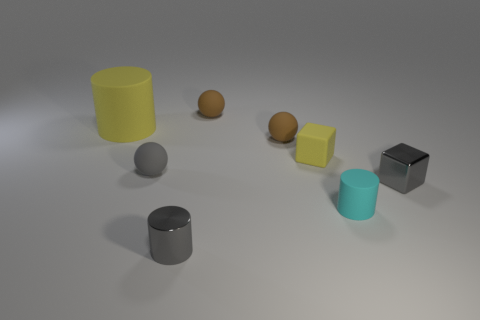Is there anything else that is the same size as the yellow cylinder?
Offer a very short reply. No. Is there anything else that is the same color as the small metallic block?
Offer a terse response. Yes. What number of other objects are the same shape as the tiny yellow matte object?
Make the answer very short. 1. Is the color of the tiny metallic cylinder the same as the metallic object that is behind the gray cylinder?
Provide a short and direct response. Yes. How many large matte cylinders are there?
Offer a very short reply. 1. How many objects are small cyan rubber spheres or small yellow matte things?
Offer a very short reply. 1. What is the size of the object that is the same color as the matte block?
Your response must be concise. Large. Are there any matte cylinders behind the big matte cylinder?
Provide a succinct answer. No. Are there more tiny gray metal cubes behind the large yellow matte thing than balls to the right of the gray ball?
Offer a terse response. No. The gray shiny thing that is the same shape as the cyan rubber object is what size?
Keep it short and to the point. Small. 